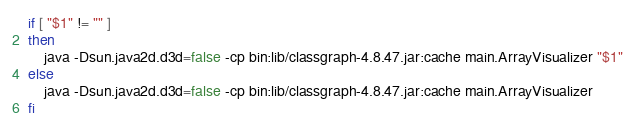Convert code to text. <code><loc_0><loc_0><loc_500><loc_500><_Bash_>if [ "$1" != "" ]
then
    java -Dsun.java2d.d3d=false -cp bin:lib/classgraph-4.8.47.jar:cache main.ArrayVisualizer "$1"
else
    java -Dsun.java2d.d3d=false -cp bin:lib/classgraph-4.8.47.jar:cache main.ArrayVisualizer
fi
</code> 